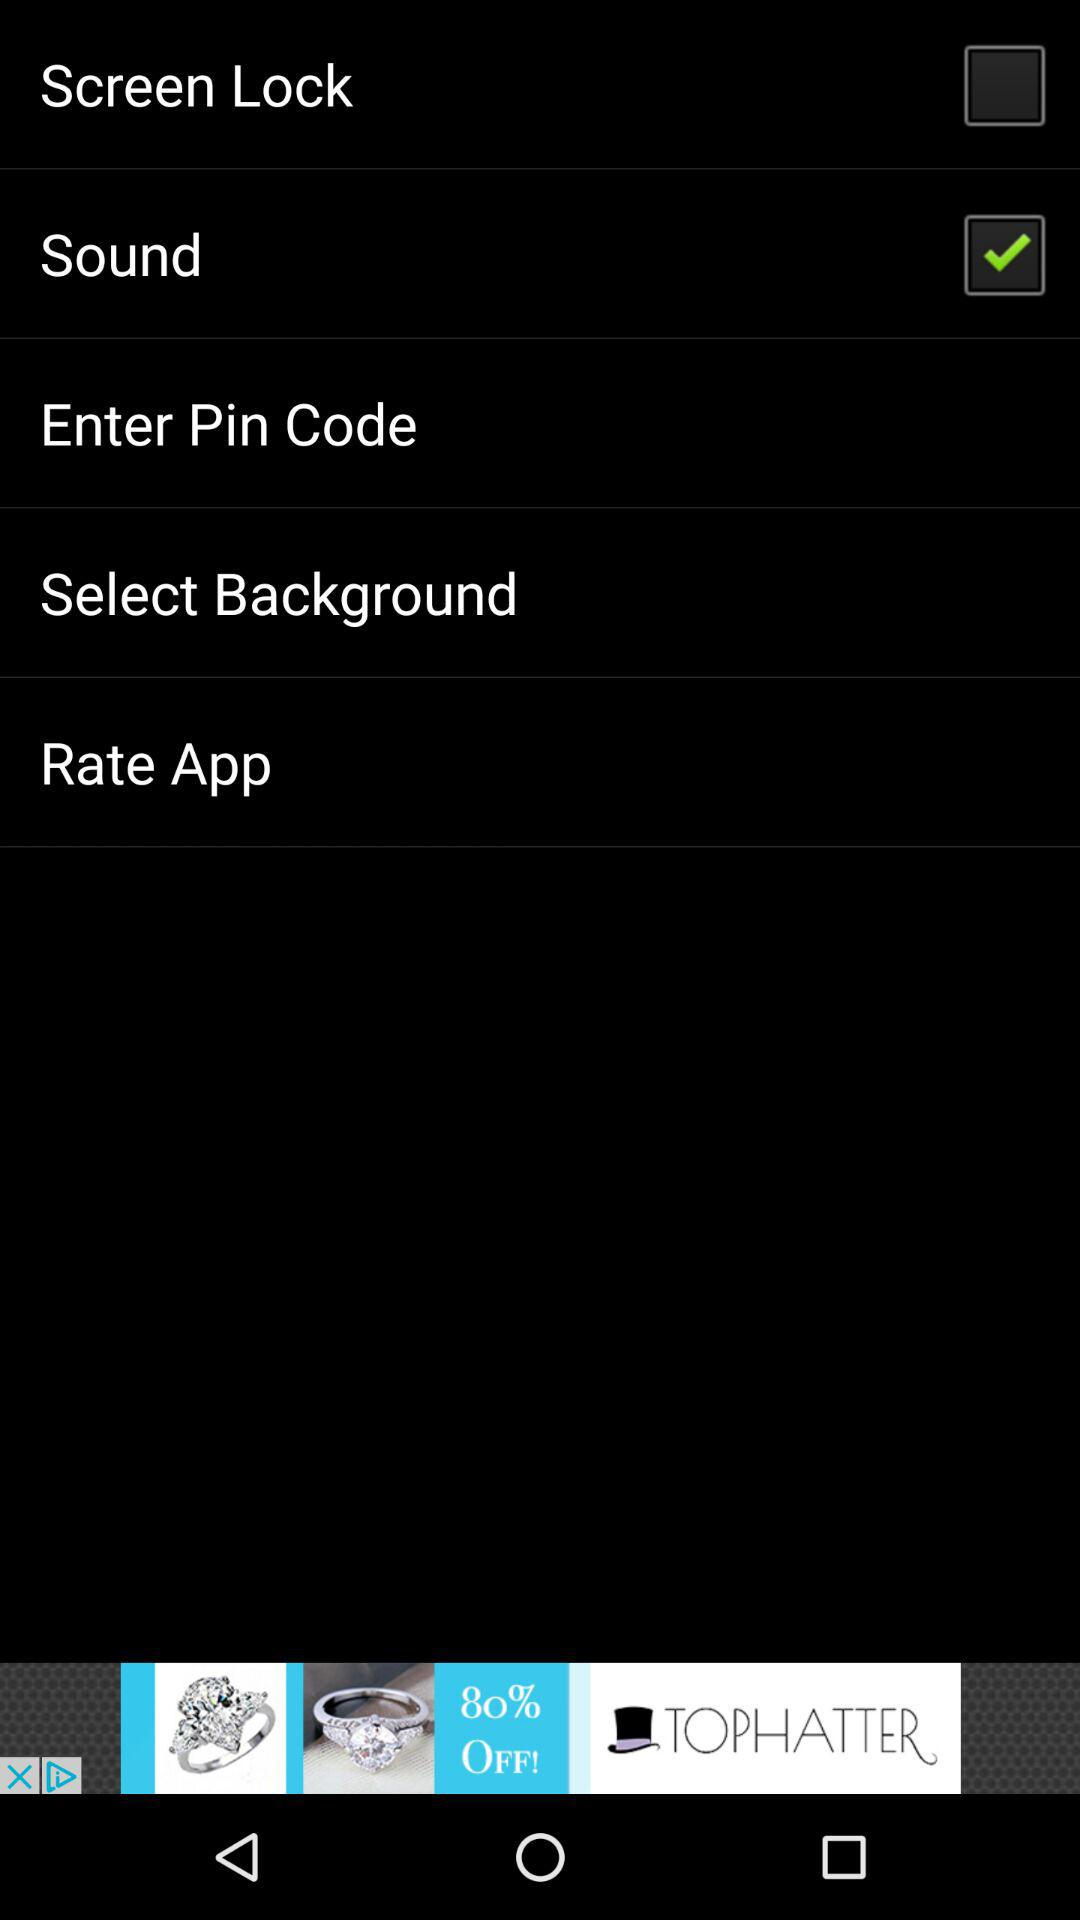How many items do not have a checkbox?
Answer the question using a single word or phrase. 3 